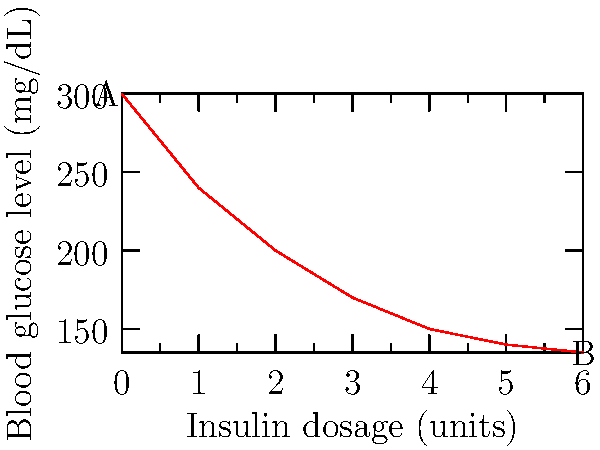The graph shows the relationship between insulin dosage and blood glucose levels in a patient with type 2 diabetes. What clinical conclusion can be drawn from the shape of the curve, particularly regarding the effectiveness of increasing insulin dosage beyond point B? To interpret this graph and draw a clinical conclusion, let's analyze it step-by-step:

1. The x-axis represents insulin dosage in units, while the y-axis shows blood glucose levels in mg/dL.

2. Point A represents the initial state with no insulin (0 units) and high blood glucose (300 mg/dL).

3. As insulin dosage increases from A to B, we observe a rapid decrease in blood glucose levels.

4. However, the rate of decrease in blood glucose levels slows down as we move towards point B.

5. Beyond point B (at 6 units of insulin), the curve appears to flatten out, suggesting minimal additional benefit in glucose reduction with further increases in insulin dosage.

6. This flattening of the curve indicates a phenomenon known as insulin resistance or diminishing returns of insulin therapy.

7. From a clinical perspective, increasing the insulin dosage beyond point B would likely provide minimal additional benefit in lowering blood glucose levels.

8. Moreover, higher insulin doses increase the risk of side effects such as hypoglycemia and weight gain.

Therefore, the shape of this curve suggests that there's a point of optimal insulin dosage (around point B) beyond which the benefits of increasing the dose are outweighed by the potential risks.
Answer: Diminishing returns of insulin therapy beyond optimal dosage 